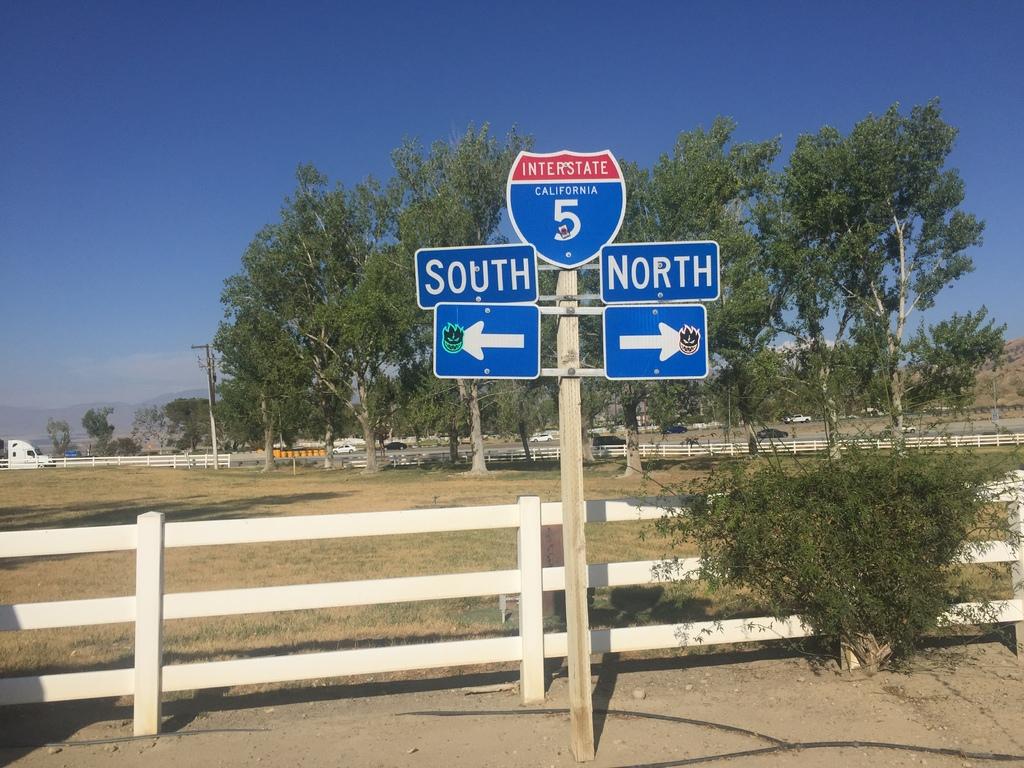Which interstate does this sign point to?
Give a very brief answer. 5. What direction do they have arrows pointing to?
Offer a very short reply. South and north. 